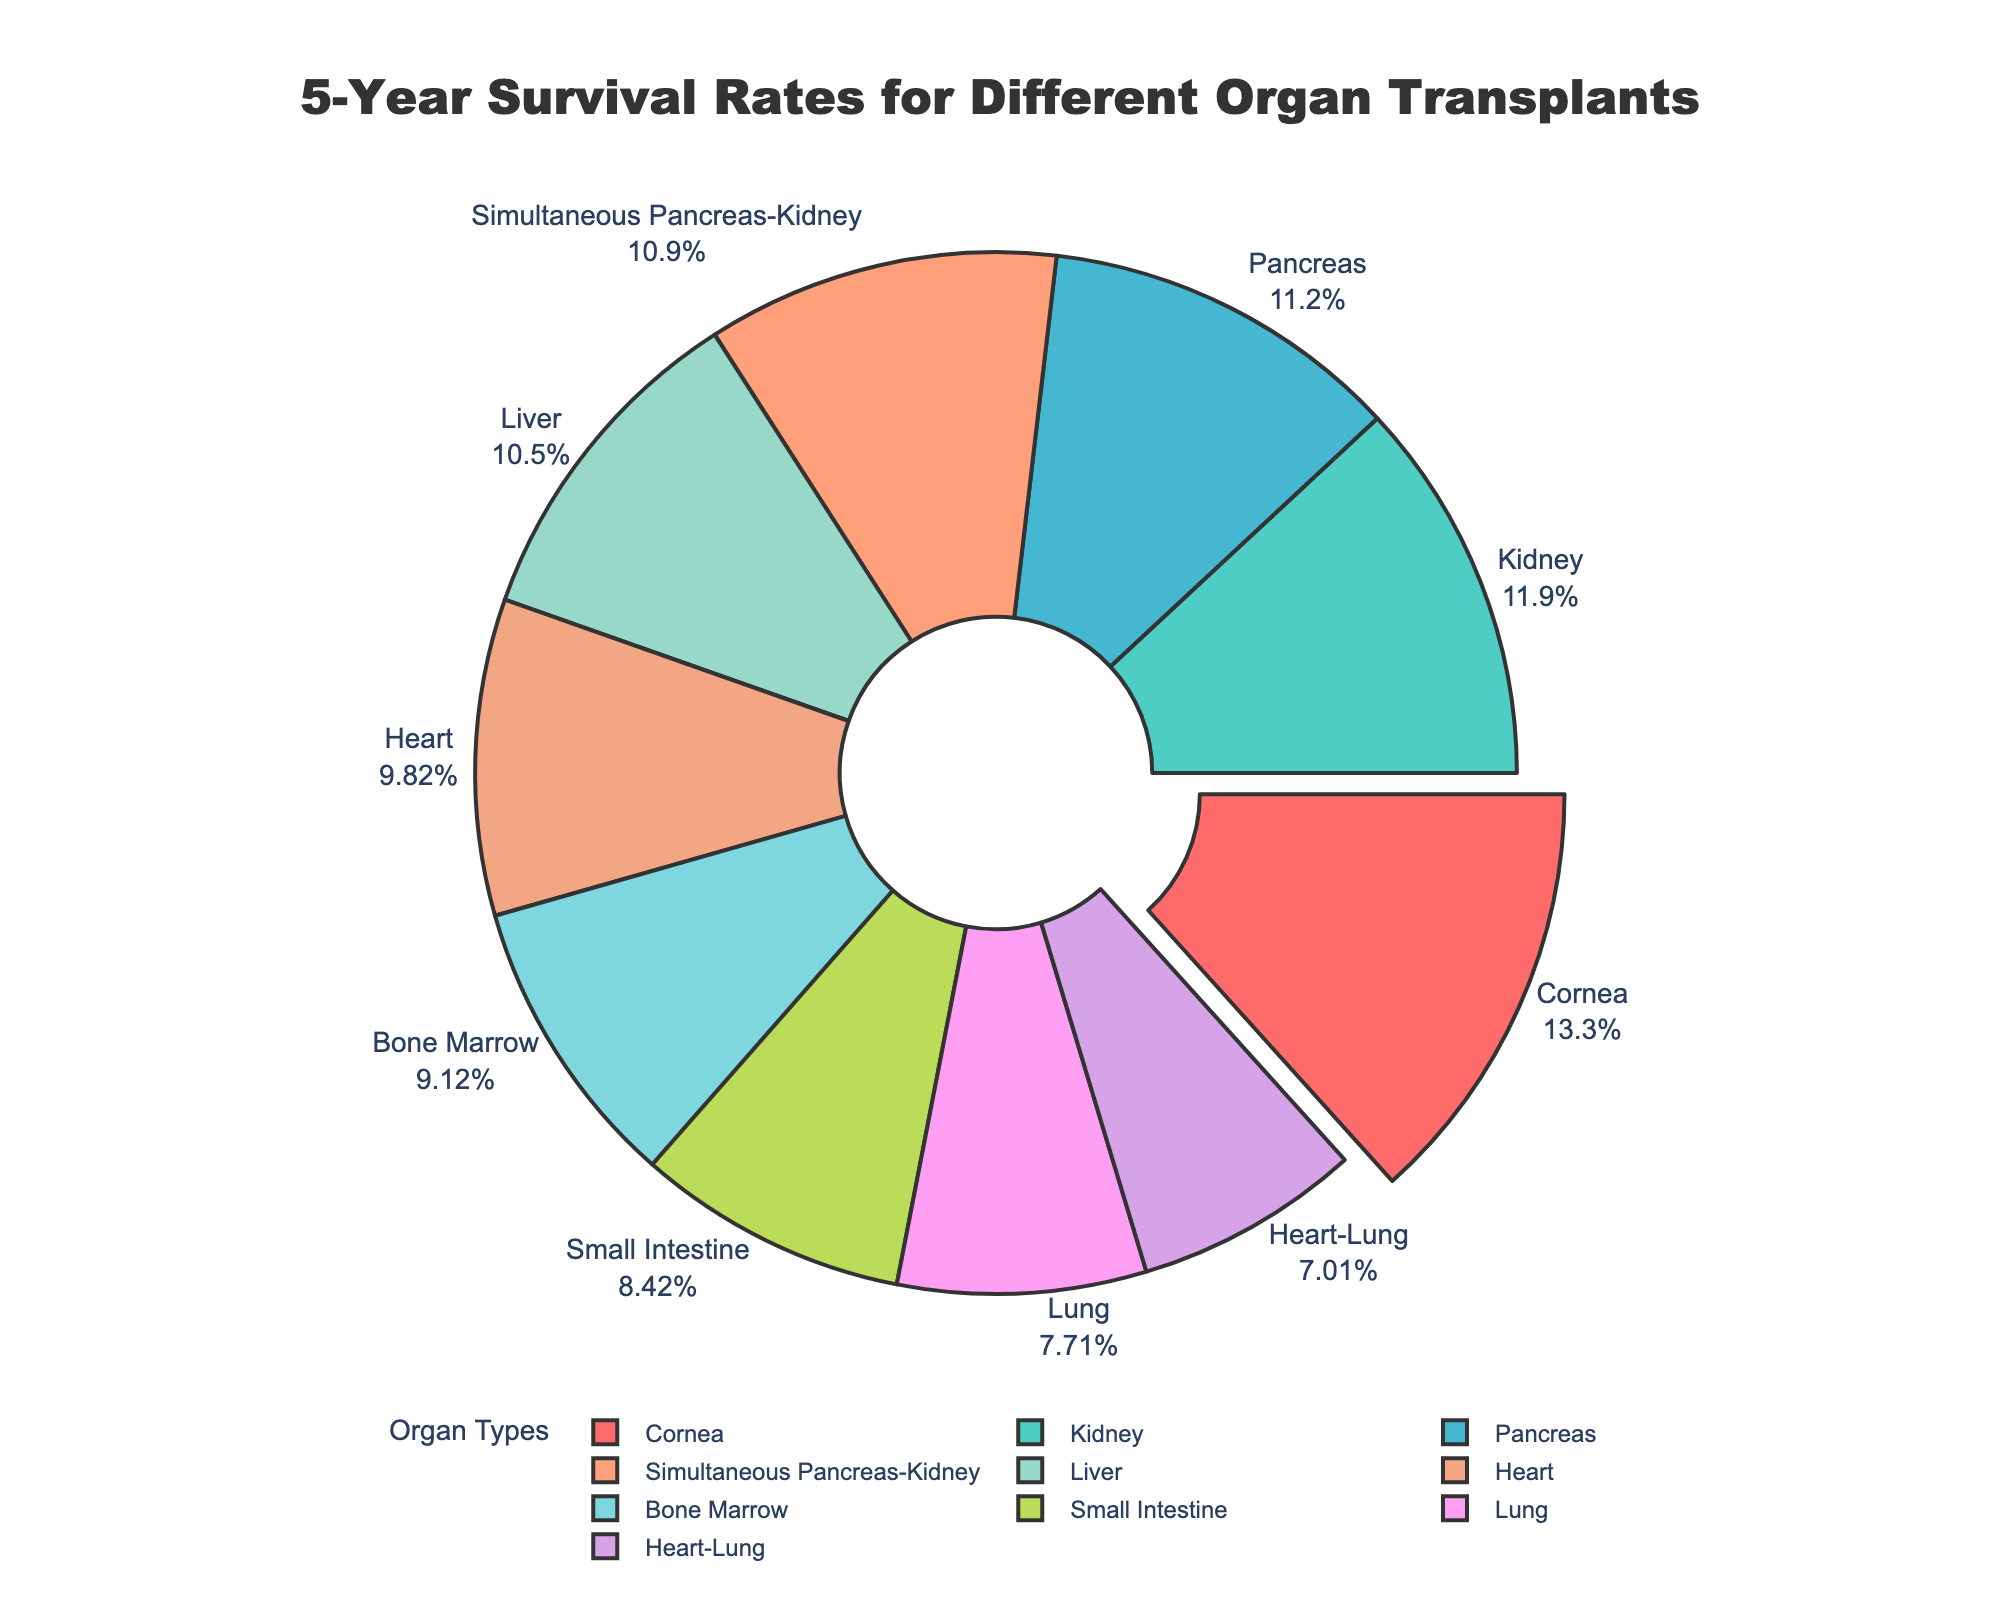Which organ transplant type has the highest 5-year survival rate? The cornea transplant shows the highest 5-year survival rate, as indicated by the largest segment in the pie chart at 95%.
Answer: Cornea Which two organ transplants have survival rates exceeding 80%? The kidney and cornea transplants show survival rates exceeding 80%. The kidney is at 85% and the cornea is at 95%, as indicated by their respective segments in the pie chart.
Answer: Kidney, Cornea Which organ transplant type has the lowest 5-year survival rate? The heart-lung transplant has the lowest 5-year survival rate, as shown by the smallest segment in the pie chart at 50%.
Answer: Heart-Lung How does the survival rate for liver transplants compare to lung transplants? The liver transplant survival rate is 75%, while the lung transplant survival rate is 55%. Thus, liver transplants have a 20% higher survival rate compared to lung transplants.
Answer: 20% higher What is the average 5-year survival rate across all the organ transplants listed? Sum all the survival rates (85 + 75 + 70 + 55 + 80 + 60 + 95 + 65 + 78 + 50 = 713) and then divide by the number of organ transplants (10). The average survival rate is 713 / 10 = 71.3%.
Answer: 71.3% If you combine the survival rates for the kidney and pancreas transplants, what percentage do they contribute to the total? The kidney and pancreas transplants have survival rates of 85% and 80%, respectively. Their combined value is 85 + 80 = 165%. The total survival rates from all transplants sum to 713%. Thus, the combined percentage is (165 / 713) * 100 ≈ 23.14%.
Answer: 23.14% Compare the 5-year survival rates of the heart and bone marrow transplants. Which is higher, and by how much? The heart transplant has a 5-year survival rate of 70%, while the bone marrow transplant has a rate of 65%. The heart transplant is higher by 5%.
Answer: 5% What is the median 5-year survival rate for the organ transplants listed? Sorting the survival rates: 50, 55, 60, 65, 70, 75, 78, 80, 85, 95, the median value is the average of the 5th and 6th values. Thus, median = (70 + 75) / 2 = 72.5%.
Answer: 72.5% Which organ transplant type, among pancreas and heart-lung, shows a significant difference in survival rate, and what is that difference? The pancreas transplant has an 80% survival rate, and the heart-lung transplant has a 50% survival rate. The difference is 80 - 50 = 30%.
Answer: 30% Identify the organ transplant with a survival rate closest to the average across all transplants. The average 5-year survival rate is 71.3%. The heart transplant has a survival rate of 70%, which is closest to the average.
Answer: Heart 